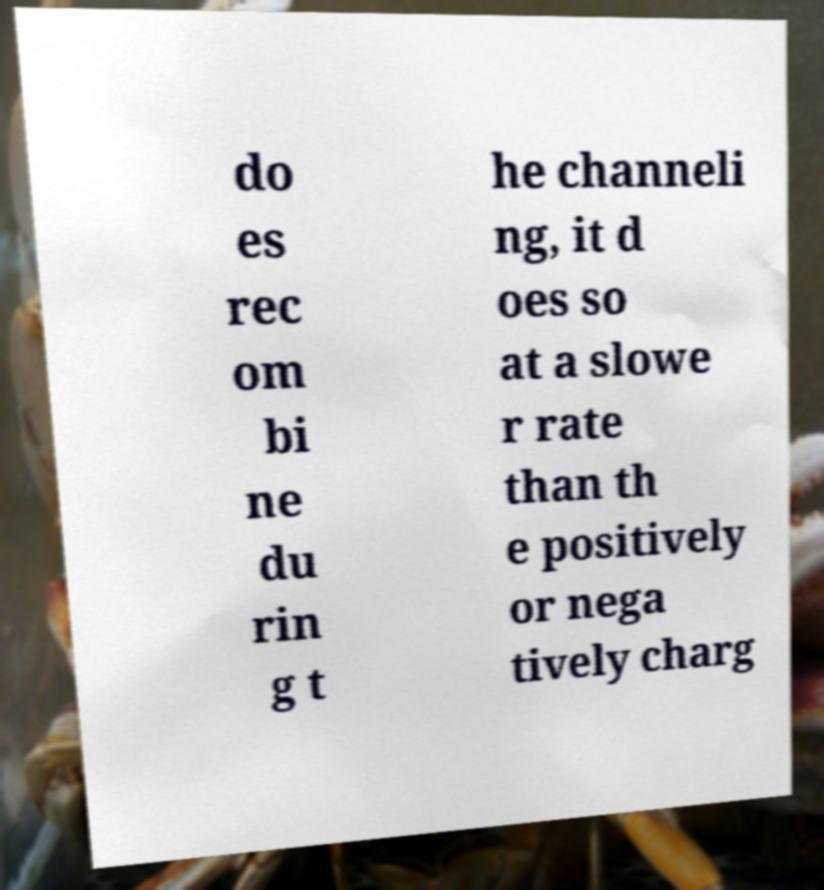What messages or text are displayed in this image? I need them in a readable, typed format. do es rec om bi ne du rin g t he channeli ng, it d oes so at a slowe r rate than th e positively or nega tively charg 